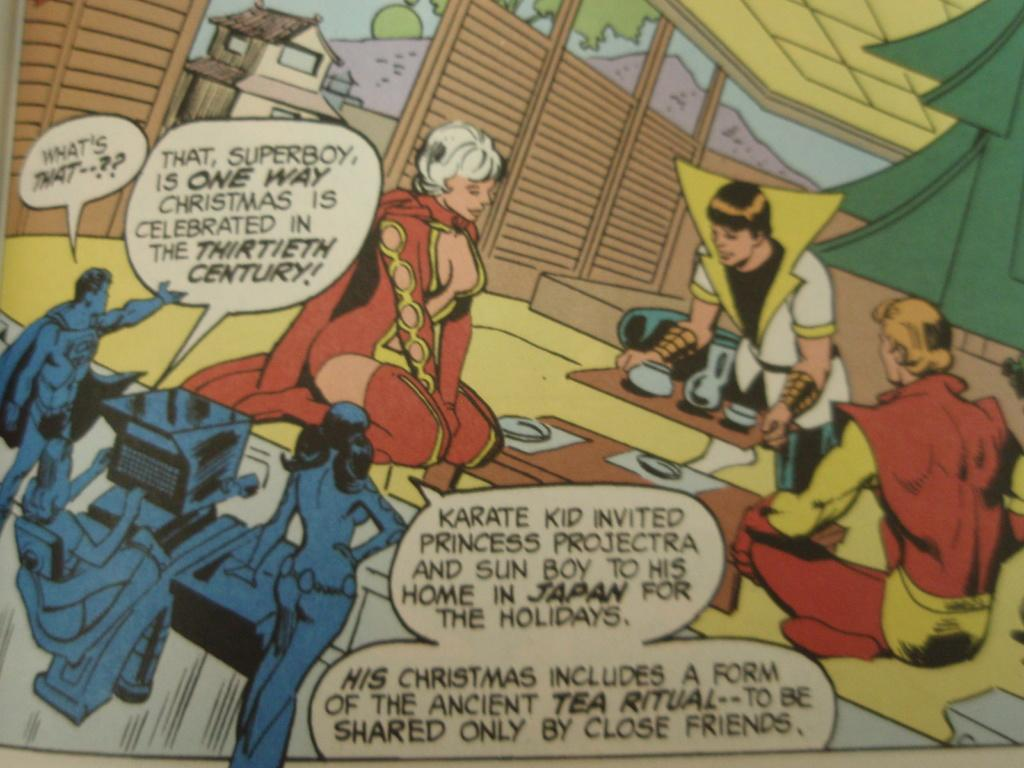<image>
Render a clear and concise summary of the photo. the word Christmas is on the front of the comic 